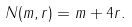<formula> <loc_0><loc_0><loc_500><loc_500>N ( m , r ) = m + 4 r .</formula> 